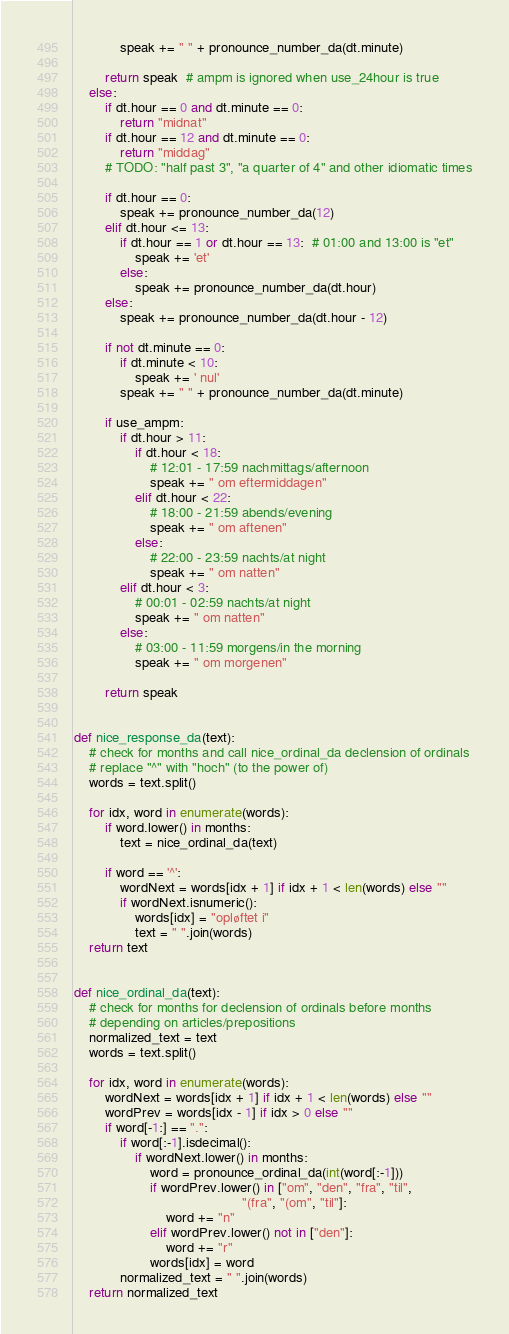Convert code to text. <code><loc_0><loc_0><loc_500><loc_500><_Python_>            speak += " " + pronounce_number_da(dt.minute)

        return speak  # ampm is ignored when use_24hour is true
    else:
        if dt.hour == 0 and dt.minute == 0:
            return "midnat"
        if dt.hour == 12 and dt.minute == 0:
            return "middag"
        # TODO: "half past 3", "a quarter of 4" and other idiomatic times

        if dt.hour == 0:
            speak += pronounce_number_da(12)
        elif dt.hour <= 13:
            if dt.hour == 1 or dt.hour == 13:  # 01:00 and 13:00 is "et"
                speak += 'et'
            else:
                speak += pronounce_number_da(dt.hour)
        else:
            speak += pronounce_number_da(dt.hour - 12)

        if not dt.minute == 0:
            if dt.minute < 10:
                speak += ' nul'
            speak += " " + pronounce_number_da(dt.minute)

        if use_ampm:
            if dt.hour > 11:
                if dt.hour < 18:
                    # 12:01 - 17:59 nachmittags/afternoon
                    speak += " om eftermiddagen"
                elif dt.hour < 22:
                    # 18:00 - 21:59 abends/evening
                    speak += " om aftenen"
                else:
                    # 22:00 - 23:59 nachts/at night
                    speak += " om natten"
            elif dt.hour < 3:
                # 00:01 - 02:59 nachts/at night
                speak += " om natten"
            else:
                # 03:00 - 11:59 morgens/in the morning
                speak += " om morgenen"

        return speak


def nice_response_da(text):
    # check for months and call nice_ordinal_da declension of ordinals
    # replace "^" with "hoch" (to the power of)
    words = text.split()

    for idx, word in enumerate(words):
        if word.lower() in months:
            text = nice_ordinal_da(text)

        if word == '^':
            wordNext = words[idx + 1] if idx + 1 < len(words) else ""
            if wordNext.isnumeric():
                words[idx] = "opløftet i"
                text = " ".join(words)
    return text


def nice_ordinal_da(text):
    # check for months for declension of ordinals before months
    # depending on articles/prepositions
    normalized_text = text
    words = text.split()

    for idx, word in enumerate(words):
        wordNext = words[idx + 1] if idx + 1 < len(words) else ""
        wordPrev = words[idx - 1] if idx > 0 else ""
        if word[-1:] == ".":
            if word[:-1].isdecimal():
                if wordNext.lower() in months:
                    word = pronounce_ordinal_da(int(word[:-1]))
                    if wordPrev.lower() in ["om", "den", "fra", "til",
                                            "(fra", "(om", "til"]:
                        word += "n"
                    elif wordPrev.lower() not in ["den"]:
                        word += "r"
                    words[idx] = word
            normalized_text = " ".join(words)
    return normalized_text
</code> 